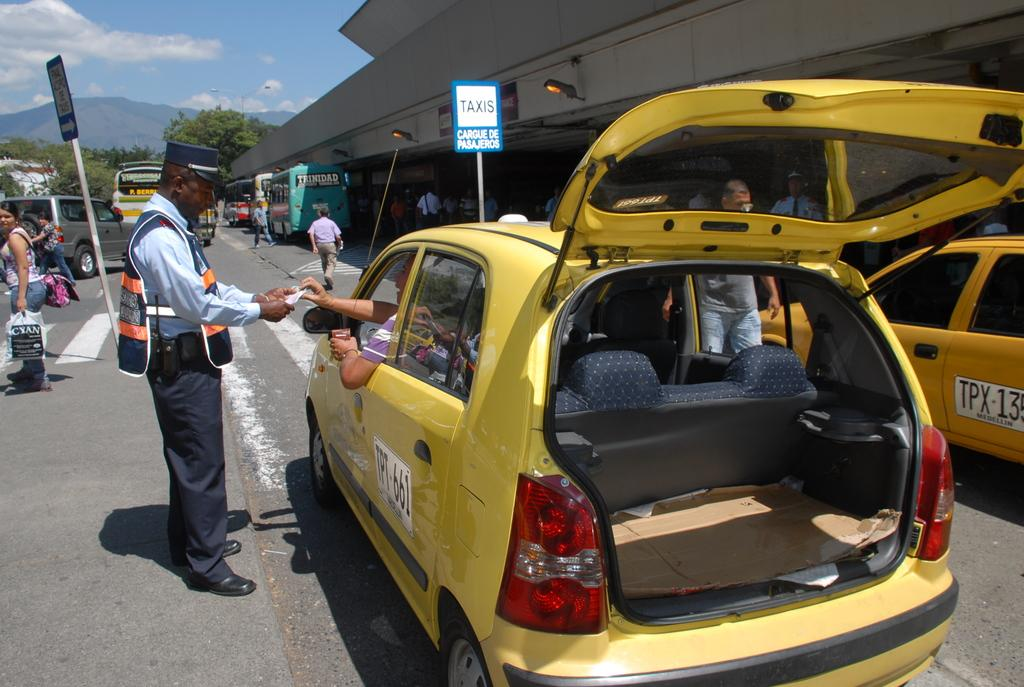<image>
Relay a brief, clear account of the picture shown. Yellow taxi parked near a sign that says TAXIS. 